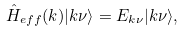Convert formula to latex. <formula><loc_0><loc_0><loc_500><loc_500>\hat { H } _ { e f f } ( k ) | k \nu \rangle = E _ { k \nu } | k \nu \rangle ,</formula> 